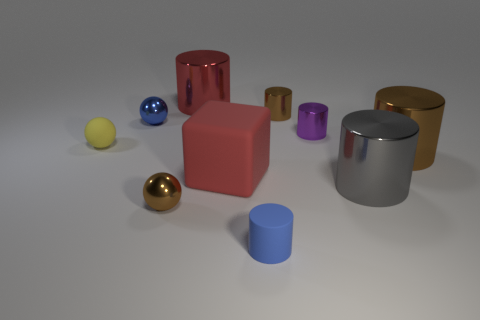Subtract 1 cylinders. How many cylinders are left? 5 Subtract all purple cylinders. How many cylinders are left? 5 Subtract all small purple cylinders. How many cylinders are left? 5 Subtract all blue cylinders. Subtract all green balls. How many cylinders are left? 5 Subtract all cubes. How many objects are left? 9 Add 8 matte blocks. How many matte blocks are left? 9 Add 6 red rubber cubes. How many red rubber cubes exist? 7 Subtract 0 purple cubes. How many objects are left? 10 Subtract all tiny rubber balls. Subtract all big red metal cylinders. How many objects are left? 8 